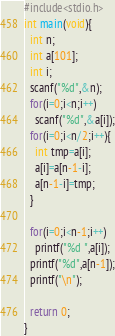Convert code to text. <code><loc_0><loc_0><loc_500><loc_500><_C_>#include<stdio.h>
int main(void){
  int n;
  int a[101];
  int i;
  scanf("%d",&n);
  for(i=0;i<n;i++)
    scanf("%d",&a[i]);
  for(i=0;i<n/2;i++){
    int tmp=a[i];
    a[i]=a[n-1-i];
    a[n-1-i]=tmp;
  }

  for(i=0;i<n-1;i++)
    printf("%d ",a[i]);
  printf("%d",a[n-1]);
  printf("\n");

  return 0;
}</code> 